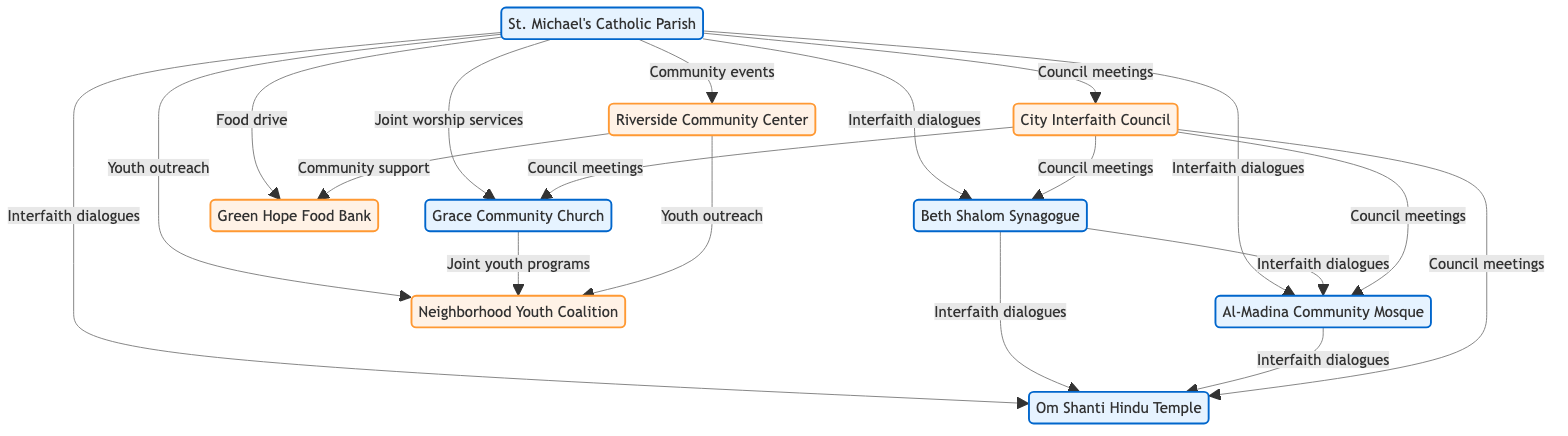What is the total number of nodes in the diagram? The diagram lists a total of 9 nodes representing various institutions and organizations.
Answer: 9 How many edges are connected to St. Michael's Catholic Parish? St. Michael's Catholic Parish has 7 edges connecting it to other nodes in the network.
Answer: 7 What type of activities are represented by the edge between St. Michael's Catholic Parish and Local Church? The edge from St. Michael's Catholic Parish to Local Church represents "Joint worship services."
Answer: Joint worship services Which two nodes are connected through "Community support"? The edge labeled "Community support" connects Riverside Community Center to Green Hope Food Bank.
Answer: Riverside Community Center and Green Hope Food Bank How many different types of dialogues are established between the local religious institutions? There are 3 specific edges labeled "Interfaith dialogues" among the religious institutions.
Answer: 3 Which organization collaborates with the Youth Group on joint youth programs? The Local Church collaborates with the Youth Group on joint youth programs as indicated by the edge labeled "Joint youth programs."
Answer: Local Church What is the connection between St. Michael's Catholic Parish and the City Interfaith Council? St. Michael's Catholic Parish is connected to the City Interfaith Council through "Council meetings."
Answer: Council meetings Which node connects all religious institutions through Council meetings? The City Interfaith Council connects all religious institutions as it has edges leading to each of them for "Council meetings."
Answer: City Interfaith Council How do Local Synagogue and Community Mosque interact? They are connected through "Interfaith dialogues."
Answer: Interfaith dialogues 